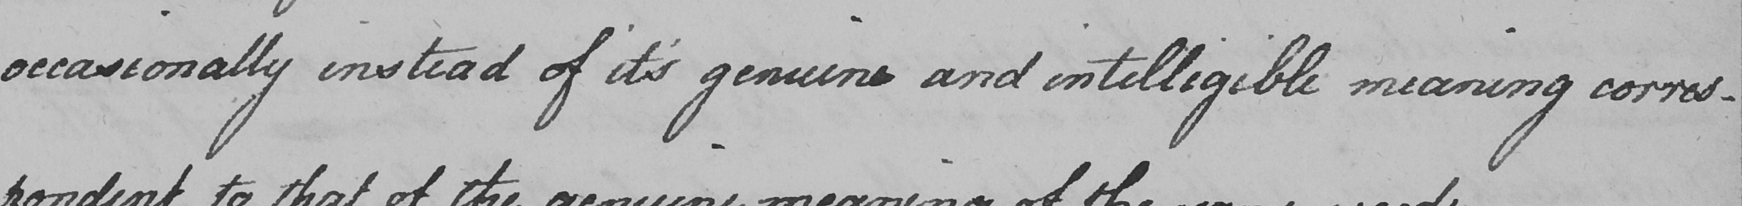What does this handwritten line say? occasionally instead of it ' s genuine and intelligible meaning corres- 